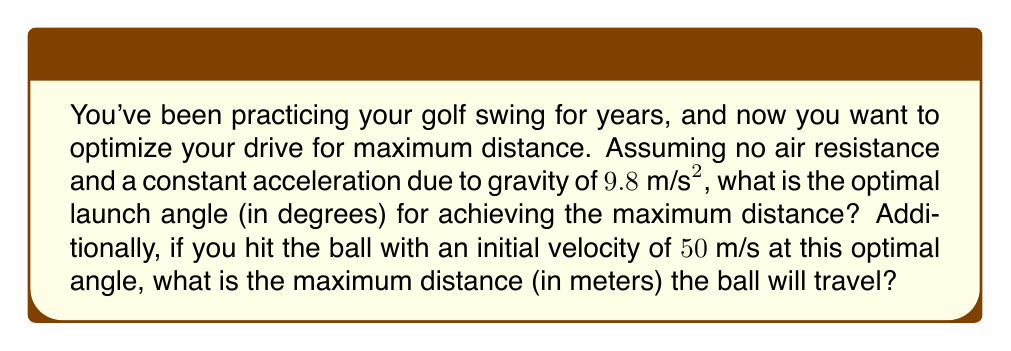Teach me how to tackle this problem. To solve this problem, we'll use the principles of projectile motion and optimization.

1) In projectile motion without air resistance, the trajectory of the golf ball forms a parabola. The range (horizontal distance) $R$ of the projectile is given by:

   $$R = \frac{v_0^2 \sin(2\theta)}{g}$$

   Where $v_0$ is the initial velocity, $\theta$ is the launch angle, and $g$ is the acceleration due to gravity.

2) To find the optimal angle, we need to maximize $R$ with respect to $\theta$. The maximum occurs when the derivative of $R$ with respect to $\theta$ is zero:

   $$\frac{dR}{d\theta} = \frac{2v_0^2 \cos(2\theta)}{g} = 0$$

3) This occurs when $\cos(2\theta) = 0$, which happens when $2\theta = 90°$ or $\theta = 45°$.

4) Therefore, the optimal launch angle for maximum distance is 45°.

5) Now, to calculate the maximum distance, we substitute $\theta = 45°$, $v_0 = 50 \text{ m/s}$, and $g = 9.8 \text{ m/s}^2$ into the range equation:

   $$R = \frac{(50 \text{ m/s})^2 \sin(2 \cdot 45°)}{9.8 \text{ m/s}^2}$$

6) Simplify:
   $$R = \frac{2500 \text{ m}^2/\text{s}^2 \cdot 1}{9.8 \text{ m/s}^2} = 255.1 \text{ m}$$

Therefore, the maximum distance the golf ball will travel is approximately 255.1 meters.
Answer: The optimal launch angle is 45°, and the maximum distance the golf ball will travel is 255.1 meters. 